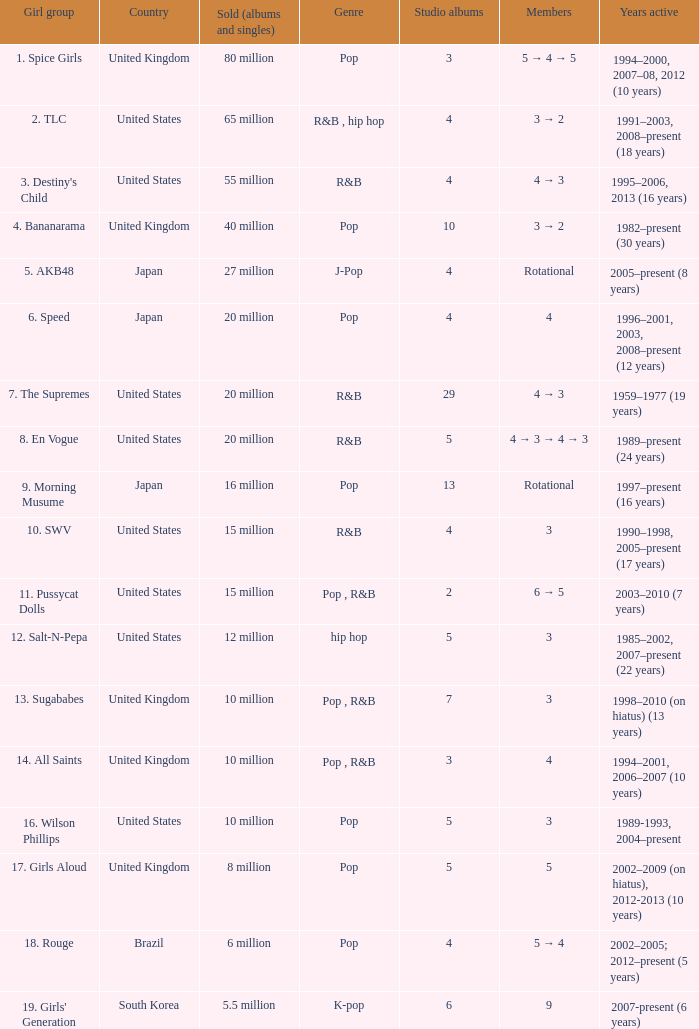Which group produced 29 studio albums? 7. The Supremes. 